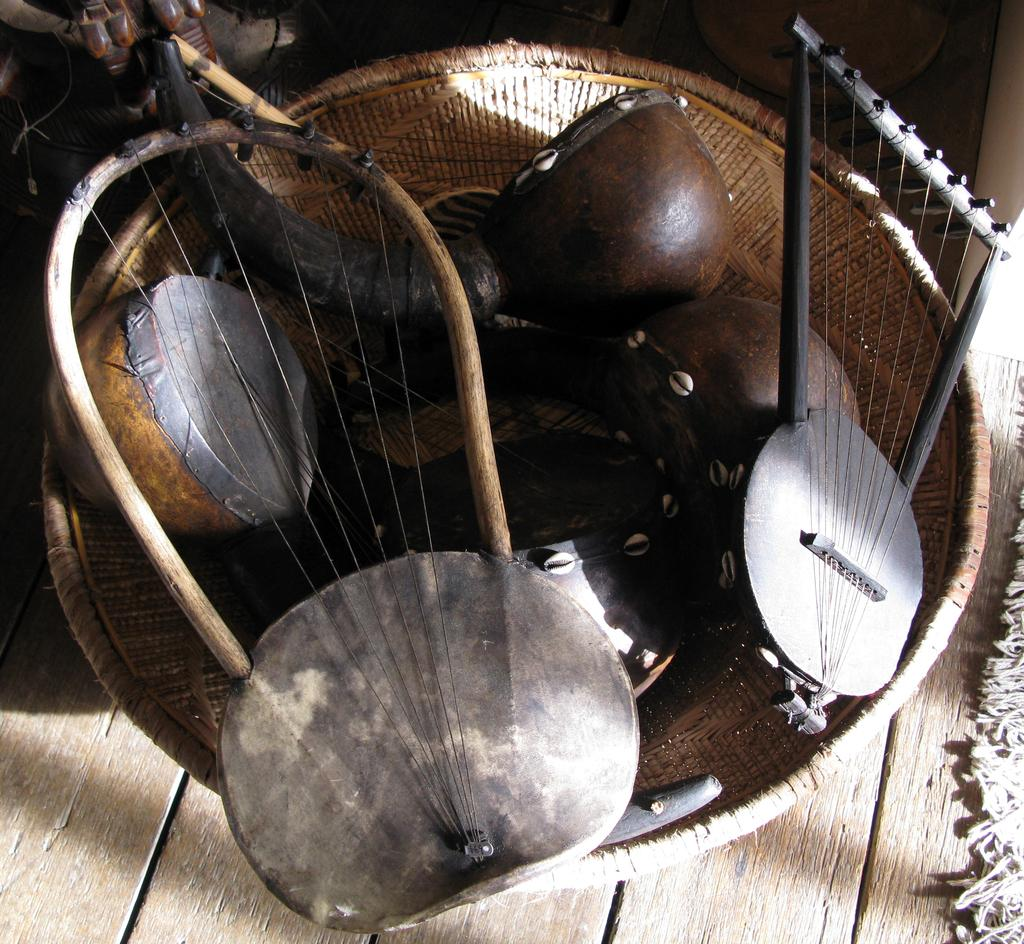What is the main object in the center of the image? There is a wooden object in the center of the image. What is placed on top of the wooden object? There is a mat on the wooden object. What shape is the object on the wooden object? There is a bowl-shaped object on the wooden object. What type of items are present on the wooden object? Musical instruments are present on the wooden object. Are there any other objects on the wooden object? Yes, there are a few other objects on the wooden object. What type of pancake is being served on the wooden object in the image? There is no pancake present in the image; the wooden object contains a mat, a bowl-shaped object, musical instruments, and a few other objects. 